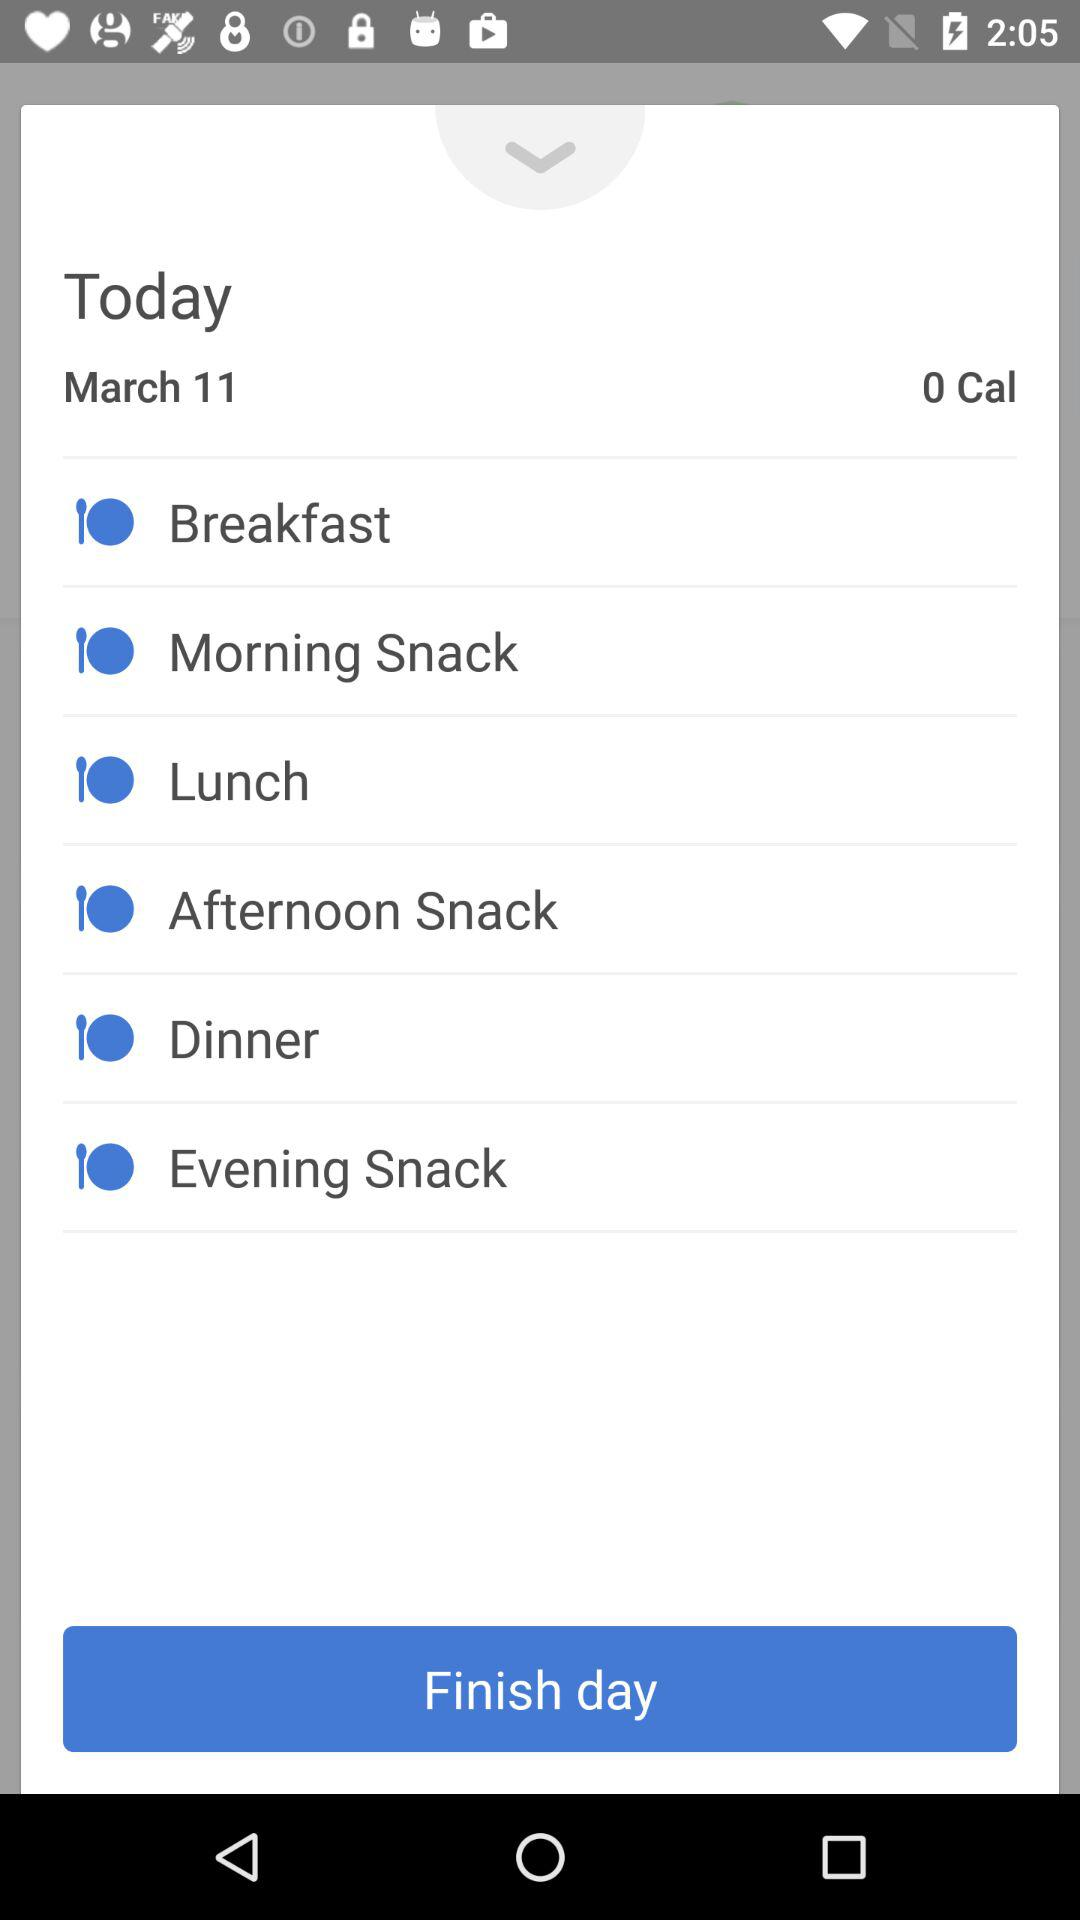How many calories are there? There are 0 calories. 